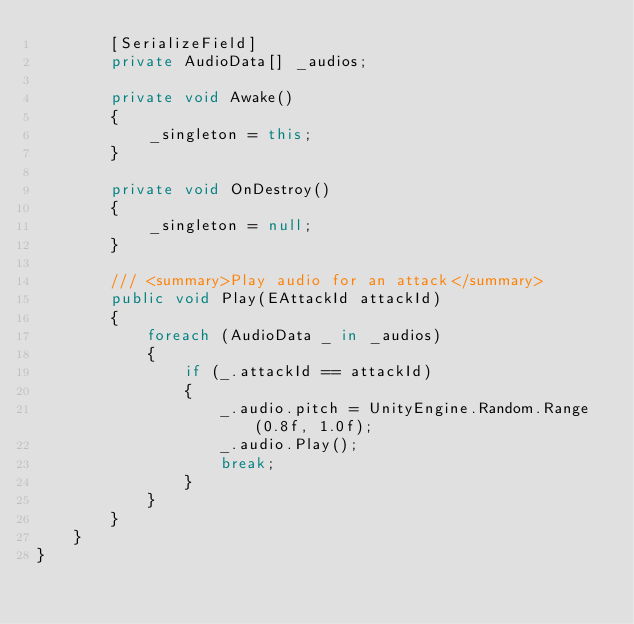Convert code to text. <code><loc_0><loc_0><loc_500><loc_500><_C#_>        [SerializeField]
        private AudioData[] _audios;

        private void Awake()
        {
            _singleton = this;
        }

        private void OnDestroy()
        {
            _singleton = null;
        }

        /// <summary>Play audio for an attack</summary>
        public void Play(EAttackId attackId)
        {
            foreach (AudioData _ in _audios)
            {
                if (_.attackId == attackId)
                {
                    _.audio.pitch = UnityEngine.Random.Range(0.8f, 1.0f);
                    _.audio.Play();
                    break;
                }
            }
        }
    }
}</code> 